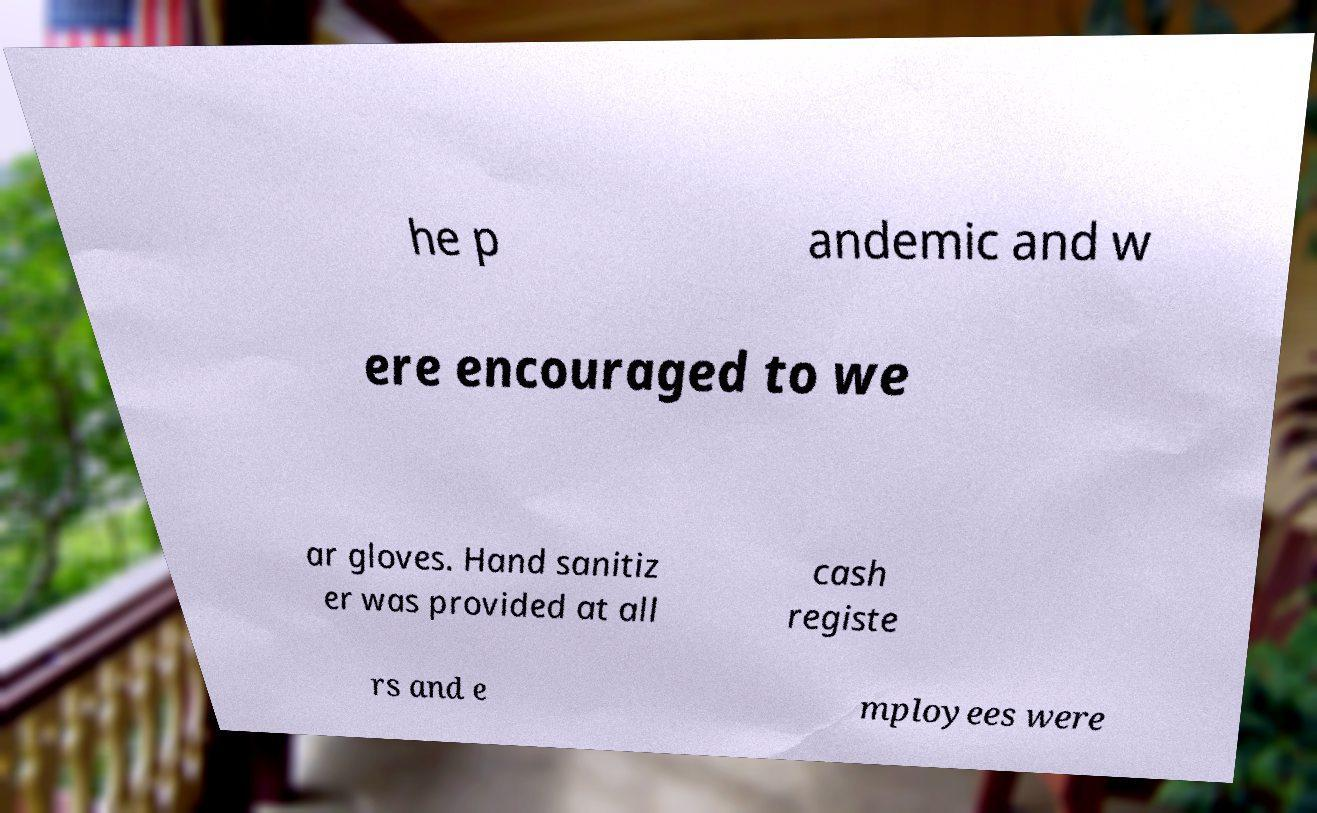Please read and relay the text visible in this image. What does it say? he p andemic and w ere encouraged to we ar gloves. Hand sanitiz er was provided at all cash registe rs and e mployees were 